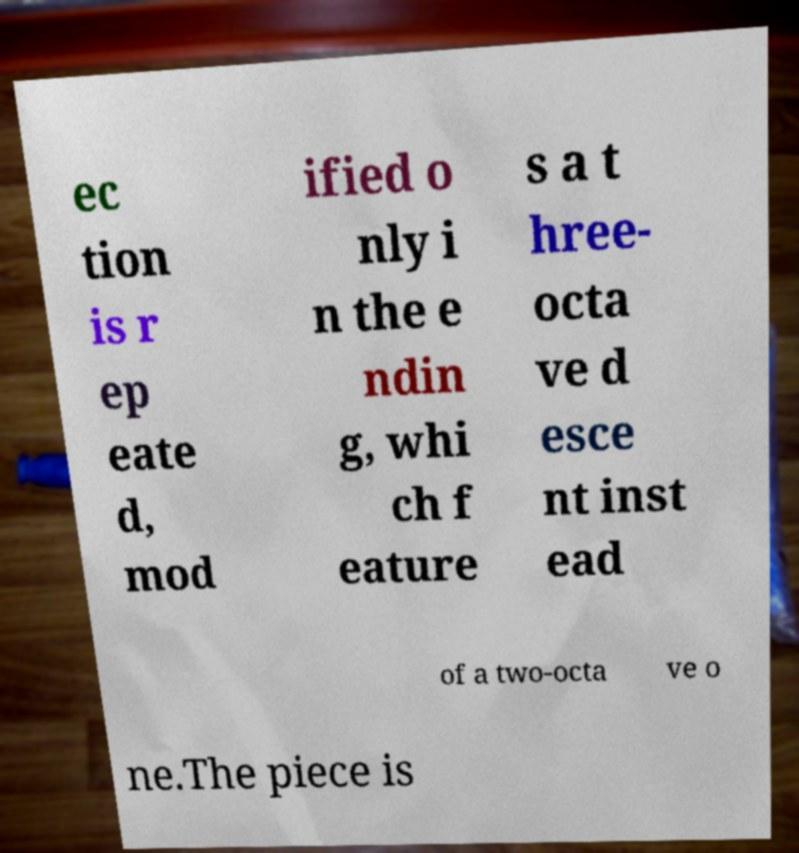There's text embedded in this image that I need extracted. Can you transcribe it verbatim? ec tion is r ep eate d, mod ified o nly i n the e ndin g, whi ch f eature s a t hree- octa ve d esce nt inst ead of a two-octa ve o ne.The piece is 